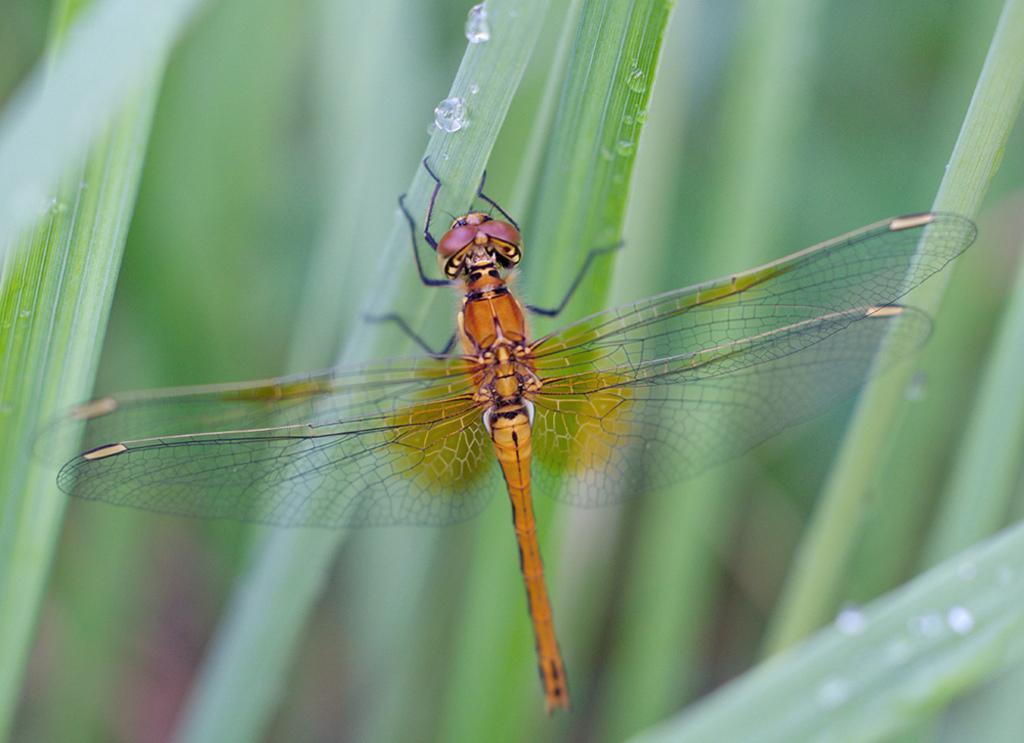Please provide a concise description of this image. In this picture I can see a dragonfly and few plants in the background and I can see water droplets on the leaves. 